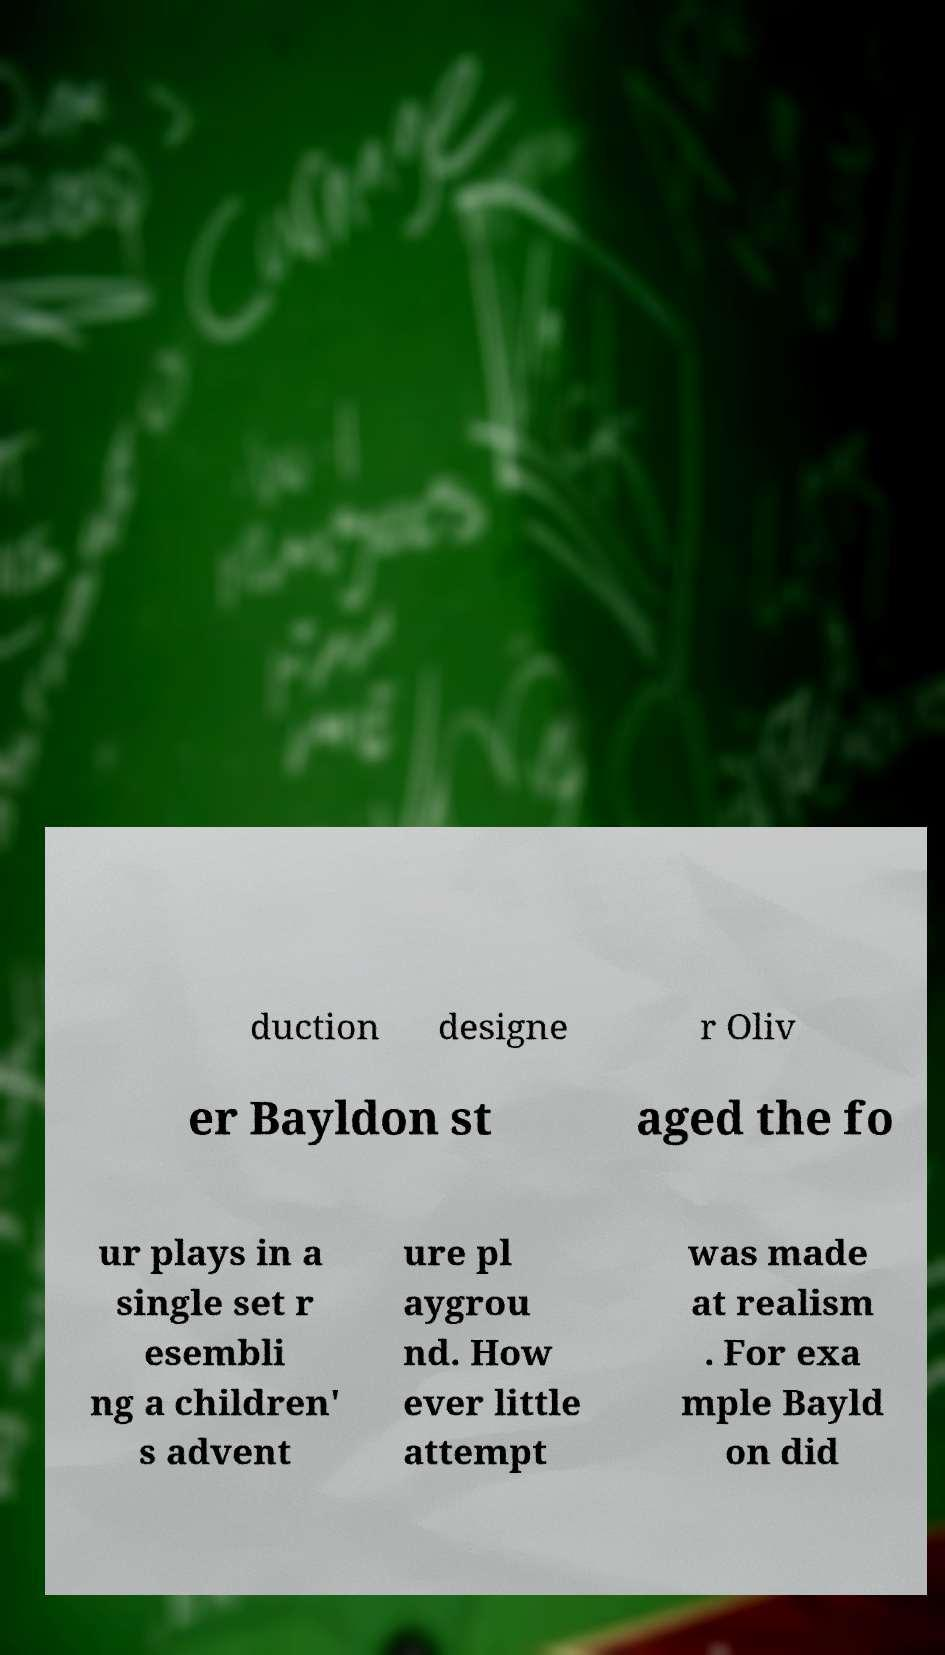Please identify and transcribe the text found in this image. duction designe r Oliv er Bayldon st aged the fo ur plays in a single set r esembli ng a children' s advent ure pl aygrou nd. How ever little attempt was made at realism . For exa mple Bayld on did 